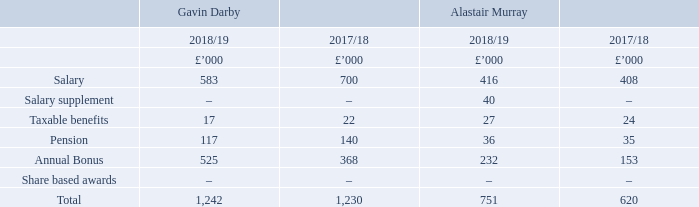Single figure table for total remuneration (audited)
Single figure for the total remuneration received by each executive director for the 52 weeks ended 30 March 2019 (2018/19) and 31 March 2018 (2017/18).
Gavin Darby
Mr Darby received a basic salary of £700,000 per annum and a salary supplement in lieu of pension of 20% of base salary on a pro rata basis for the period up to 31 January 2019. Mr Darby received a pro rata bonus of £525,500 for the financial period to 31 January 2019. Benefits were provided for the period up to 31 January 2019 relating to the provision of an executive driver service, private health insurance and annual medical assessment.
Alastair Murray
Mr Murray received a basic salary for the period of £416,201 per annum and an annualised supplement in lieu of pension of 7.5% of the Earnings Cap (£160,800 for the 2018/19 tax year) which equates to £12,060 for the period together with an additional RPI adjusted pensions supplement of £24,348. He was appointed Acting CEO on 1 February 2019, in addition to his current role of Chief Financial Officer, on a temporary basis whilst the Board conducts a search process for a new CEO.
In recognition of this significant additional responsibility, it was agreed that Mr Murray would receive a monthly salary supplement of £20,000 (which does not count towards pension, annual bonus or long-term incentives) whilst he carries out this role.
Mr Murray received a bonus of £231,615 for the financial period. Benefits related to the provision of a company car, use of an executive driver service (following his appointment as Acting CEO) and private health insurance. In line with the current Remuneration Policy, one-third of his annual bonus award will be in the form of shares deferred for three years.
Full details of the annual bonus performance assessments for Mr Darby and Mr Murray are set out on pages 53 to 55.
What was the basic salary per annum of Mr Darby in 2017/18? £700,000. What was the basic salary of Mr Murray in 2018/19? £416,201. What was the basic salary per annum of Mr Darby in 2018/19?
Answer scale should be: thousand. 583. What was the change in the salary of Gavin Darby from 2017/18 to 2018/19?
Answer scale should be: thousand. 583 - 700
Answer: -117. What is the average salary of Alastair Murray in 2017/18 and 2018/19?
Answer scale should be: thousand. (416 + 408) / 2
Answer: 412. What was the average taxable benefits for Gavin Darby for 2017/18 and 2018/19?
Answer scale should be: thousand. (17 + 22) / 2
Answer: 19.5. 